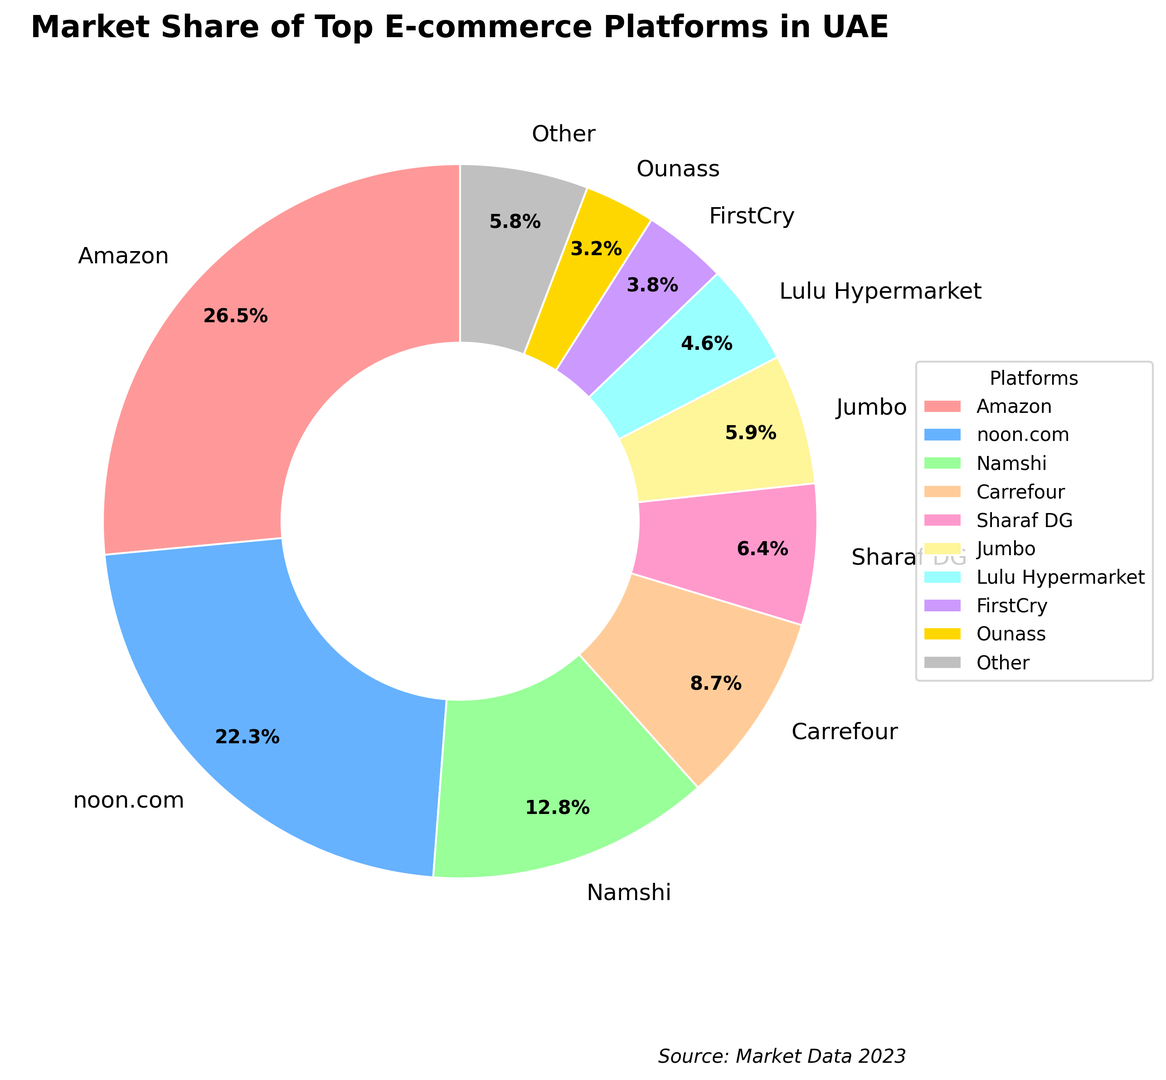What is the market share of Amazon? To find Amazon's market share, simply look at the section labeled "Amazon" in the pie chart.
Answer: 26.5% Which two platforms have the smallest market shares? To identify the platforms with the smallest market shares, look for the two smallest slices in the pie chart. These are "Ounass" and "FirstCry".
Answer: Ounass and FirstCry What is the combined market share of noon.com and Namshi? To find the combined market share of noon.com and Namshi, add their individual market shares from the chart: noon.com (22.3%) + Namshi (12.8%) = 35.1%.
Answer: 35.1% Which platform has a higher market share, Sharaf DG or Jumbo? To determine which platform has a higher market share, compare the market share percentages of Sharaf DG (6.4%) and Jumbo (5.9%) from the chart.
Answer: Sharaf DG What is the color of the section representing Carrefour? The section color representing Carrefour is visually identifiable in the pie chart. It corresponds to the fourth color used from the specified list, which is a peach-brown color.
Answer: Peach-brown How much more market share does Amazon have compared to Ounass? To find the difference in market share between Amazon and Ounass, subtract Ounass's market share from Amazon's: 26.5% - 3.2% = 23.3%.
Answer: 23.3% What is the total market share of the platforms with less than 10% market share each? To calculate the total market share of platforms with less than 10%, sum their individual market shares: Namshi (12.8%), Carrefour (8.7%), Sharaf DG (6.4%), Jumbo (5.9%), Lulu Hypermarket (4.6%), FirstCry (3.8%), Ounass (3.2%), and Other (5.8%). Exclude Namshi as it has more than 10%. So, 8.7% + 6.4% + 5.9% + 4.6% + 3.8% + 3.2% + 5.8% = 38.4%.
Answer: 38.4% What percentage of the market share is held by platforms that have over 20% each? Identify platforms with over 20% market share, which are Amazon (26.5%) and noon.com (22.3%), then add these percentages: 26.5% + 22.3% = 48.8%.
Answer: 48.8% Is Carrefour's market share greater than or less than the combined market share of Lulu Hypermarket and FirstCry? Compare Carrefour's market share (8.7%) with the combined market share of Lulu Hypermarket and FirstCry: 4.6% + 3.8% = 8.4%. Since 8.7% > 8.4%, Carrefour's market share is greater.
Answer: Greater 